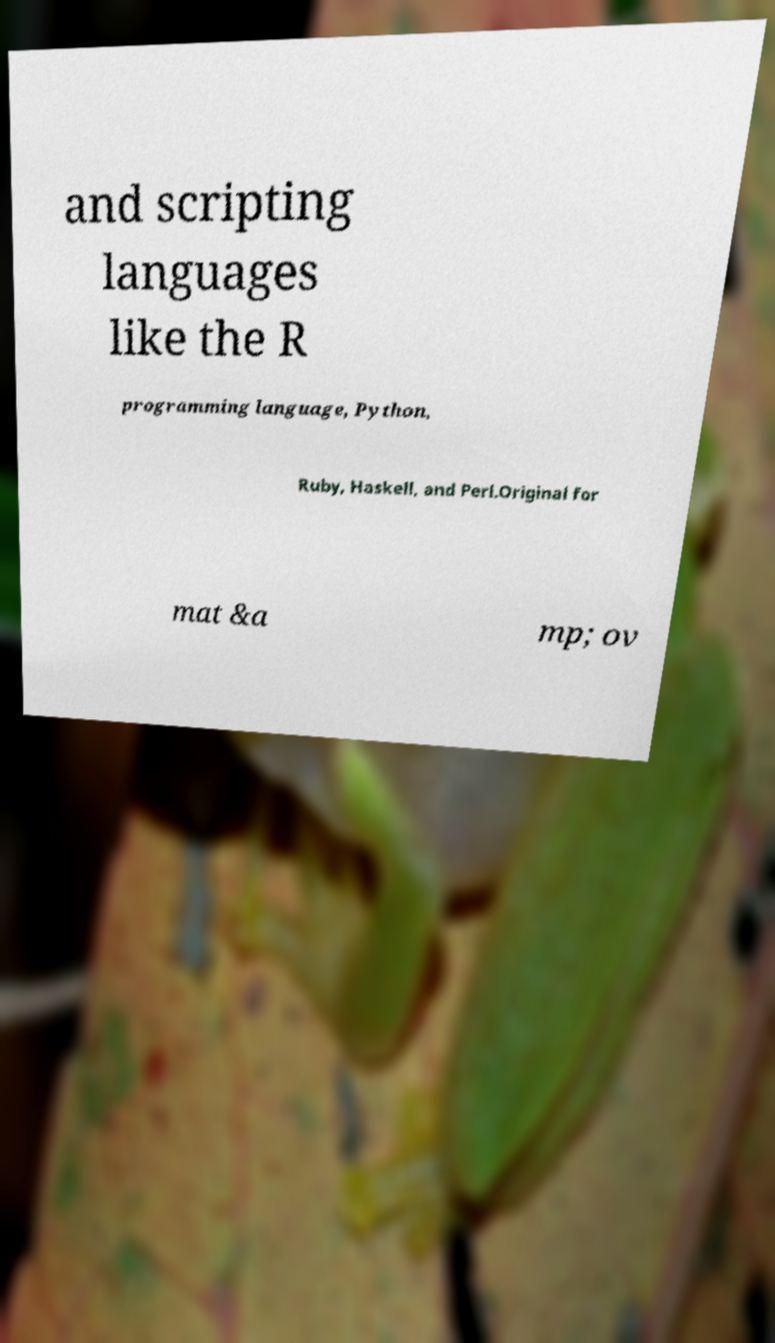Can you read and provide the text displayed in the image?This photo seems to have some interesting text. Can you extract and type it out for me? and scripting languages like the R programming language, Python, Ruby, Haskell, and Perl.Original for mat &a mp; ov 